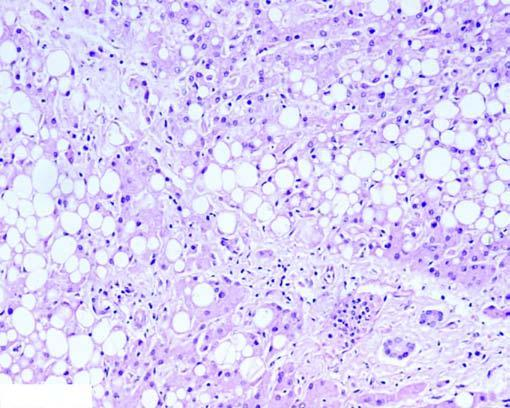re many of the hepatocytes distended with large fat vacuoles pushing the nuclei to the periphery (macrovesicles), while others show multiple small vacuoles in the cytoplasm (microvesicles)?
Answer the question using a single word or phrase. Yes 